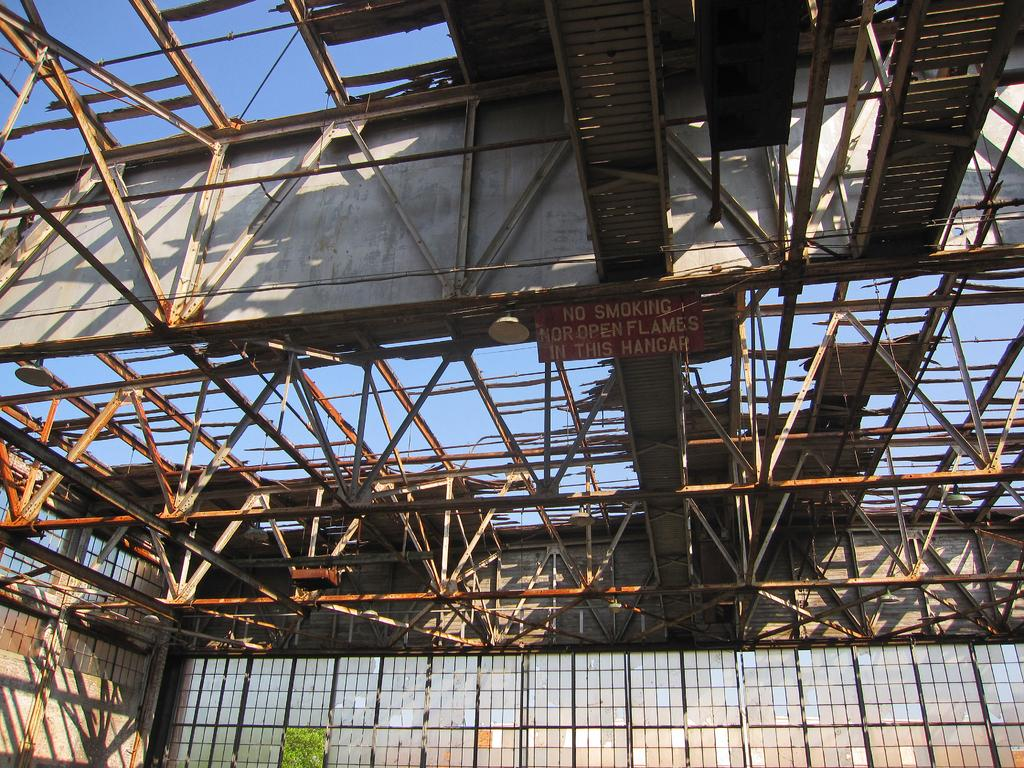What type of structure is in the image? There is a metal shed in the image. What feature can be seen on the metal shed? The metal shed has windows. What is visible at the top of the image? The sky is visible at the top of the image. How many children are playing on the scale in the image? There are no children or scales present in the image; it features a metal shed with windows and a visible sky. 